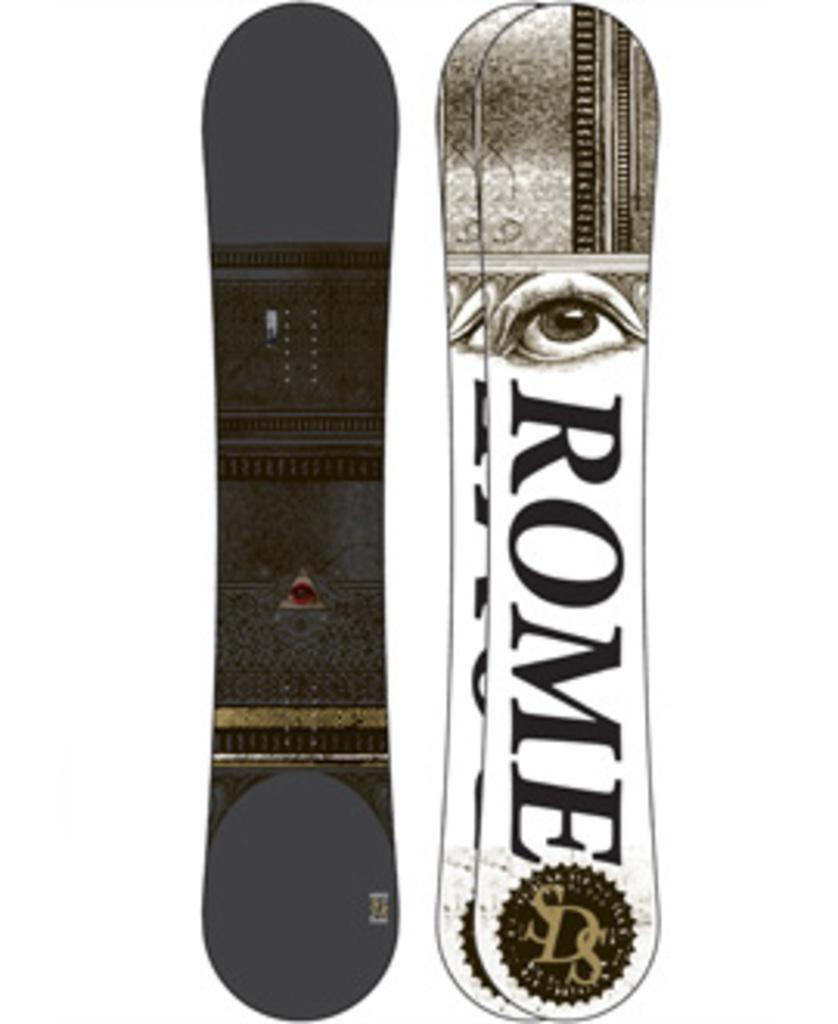What objects are present in the image? There are boards in the image. What color is the background of the image? The background of the image is white. Where are the trees located in the image? There are no trees present in the image. What is the name of the place where the boards are located? The provided facts do not give any information about the name of the place or the location of the boards. 